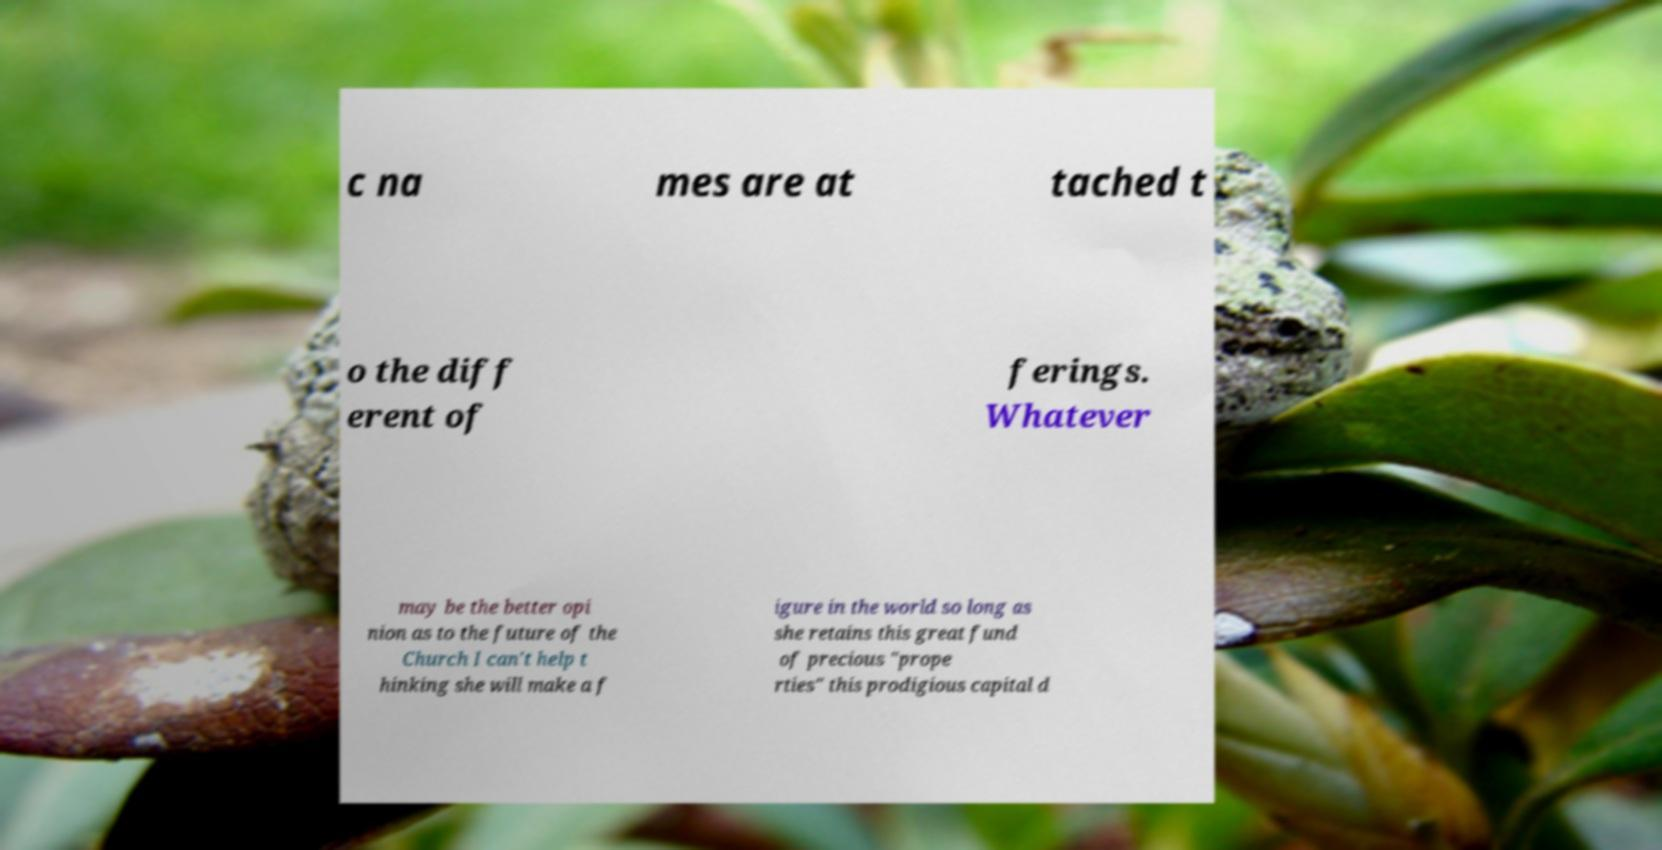Can you read and provide the text displayed in the image?This photo seems to have some interesting text. Can you extract and type it out for me? c na mes are at tached t o the diff erent of ferings. Whatever may be the better opi nion as to the future of the Church I can't help t hinking she will make a f igure in the world so long as she retains this great fund of precious "prope rties" this prodigious capital d 